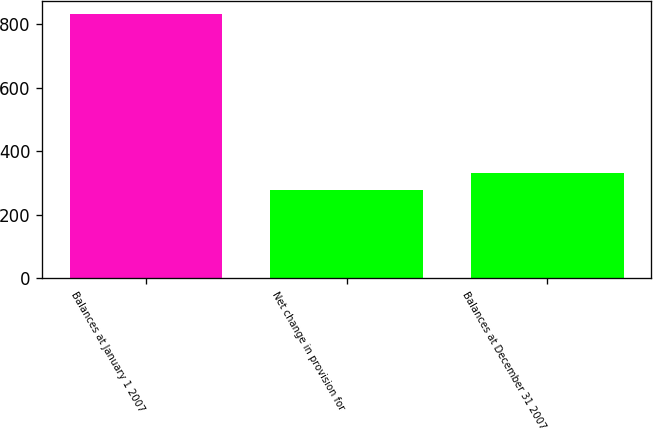Convert chart to OTSL. <chart><loc_0><loc_0><loc_500><loc_500><bar_chart><fcel>Balances at January 1 2007<fcel>Net change in provision for<fcel>Balances at December 31 2007<nl><fcel>830.7<fcel>277.7<fcel>333<nl></chart> 